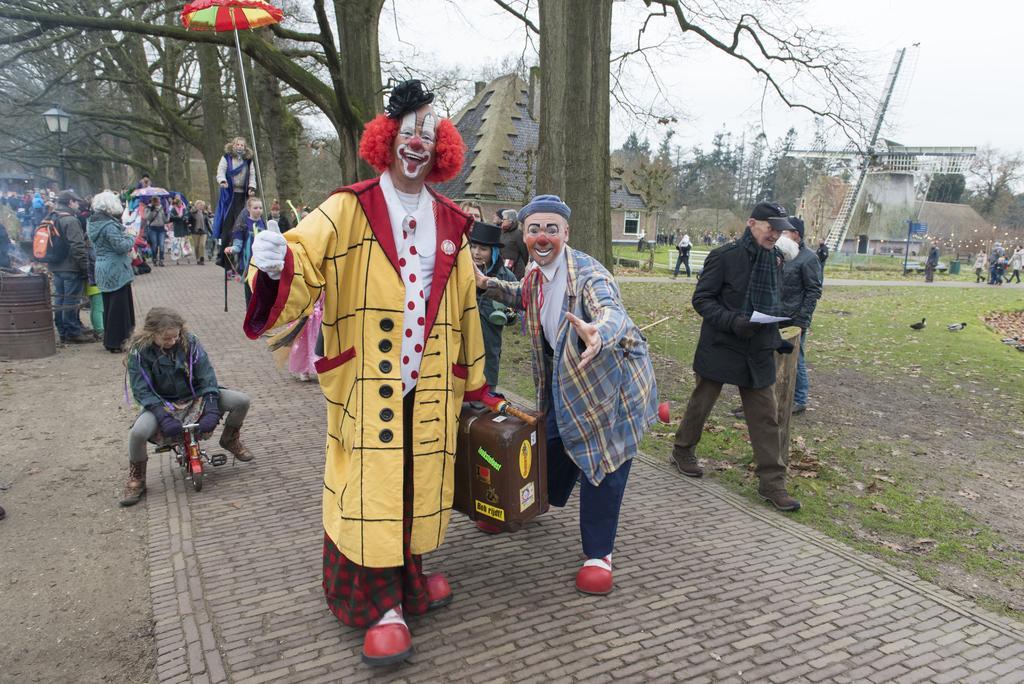Please provide a concise description of this image. In the image we can see there are many people around they are wearing clothes, some people are wearing cap, shoes and gloves. This person is sitting on the bicycle, this is a footpath, suitcase, umbrella, sticks, banner, sand, birds, grass, trees, building, bench and a sky. This is a light pole. 